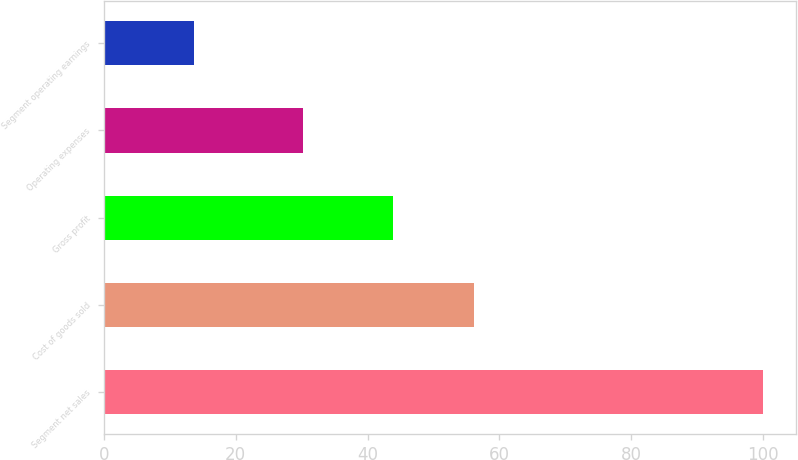Convert chart to OTSL. <chart><loc_0><loc_0><loc_500><loc_500><bar_chart><fcel>Segment net sales<fcel>Cost of goods sold<fcel>Gross profit<fcel>Operating expenses<fcel>Segment operating earnings<nl><fcel>100<fcel>56.1<fcel>43.9<fcel>30.2<fcel>13.7<nl></chart> 